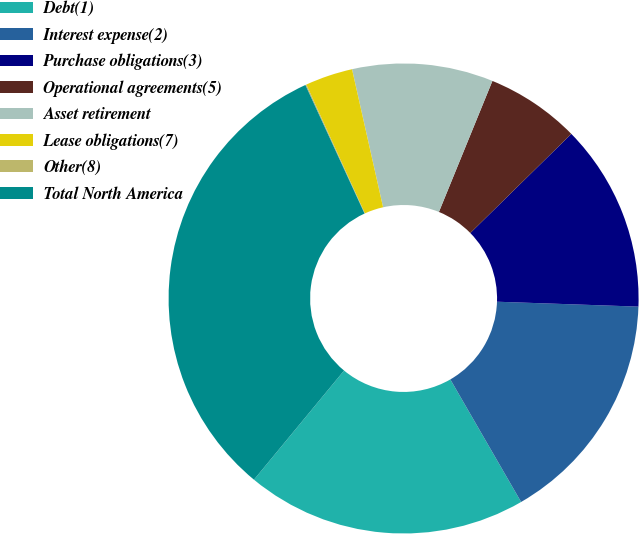<chart> <loc_0><loc_0><loc_500><loc_500><pie_chart><fcel>Debt(1)<fcel>Interest expense(2)<fcel>Purchase obligations(3)<fcel>Operational agreements(5)<fcel>Asset retirement<fcel>Lease obligations(7)<fcel>Other(8)<fcel>Total North America<nl><fcel>19.32%<fcel>16.11%<fcel>12.9%<fcel>6.48%<fcel>9.69%<fcel>3.27%<fcel>0.07%<fcel>32.15%<nl></chart> 